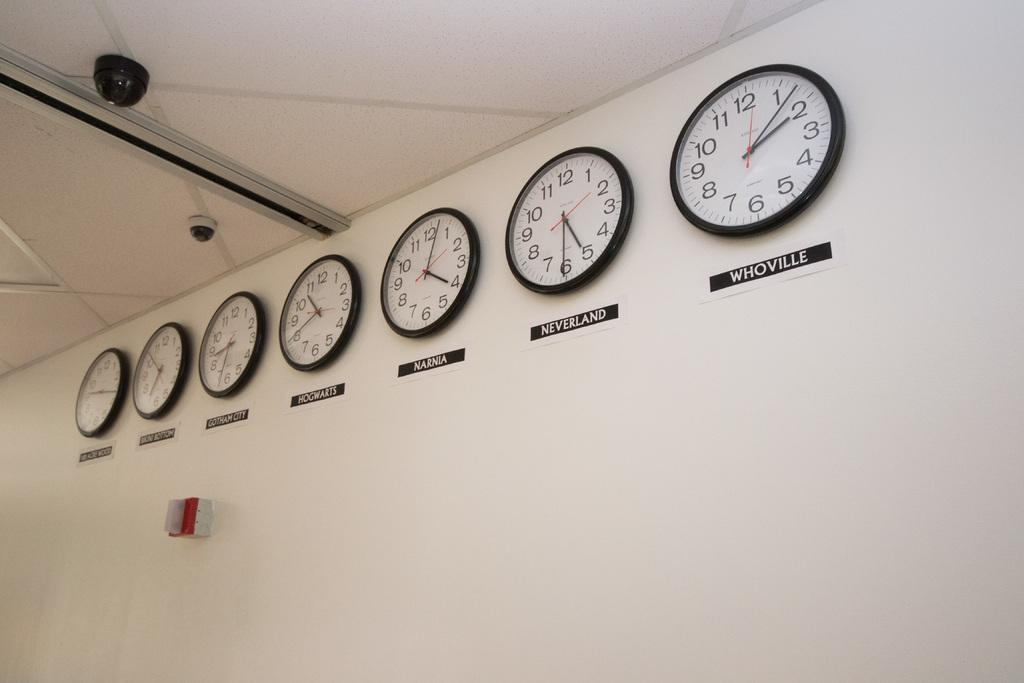<image>
Describe the image concisely. Several clocks hang from a wall with Neverland and Whoville written under two of them 